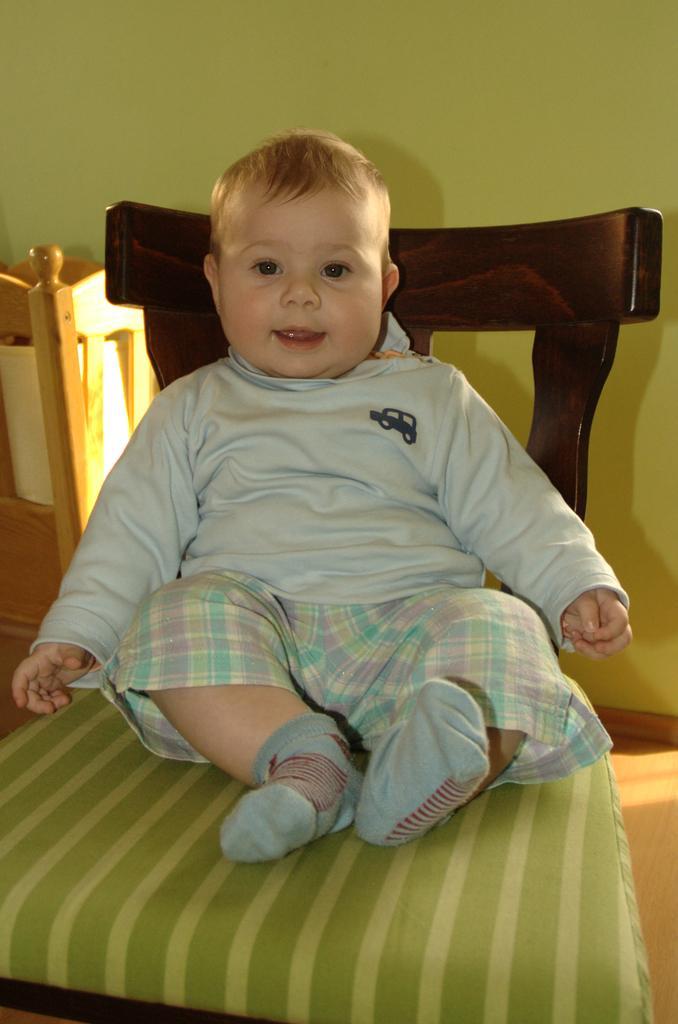Could you give a brief overview of what you see in this image? In this image we can see a kid is sitting on a chair. In the background we can see a wooden object, floor and wall. 